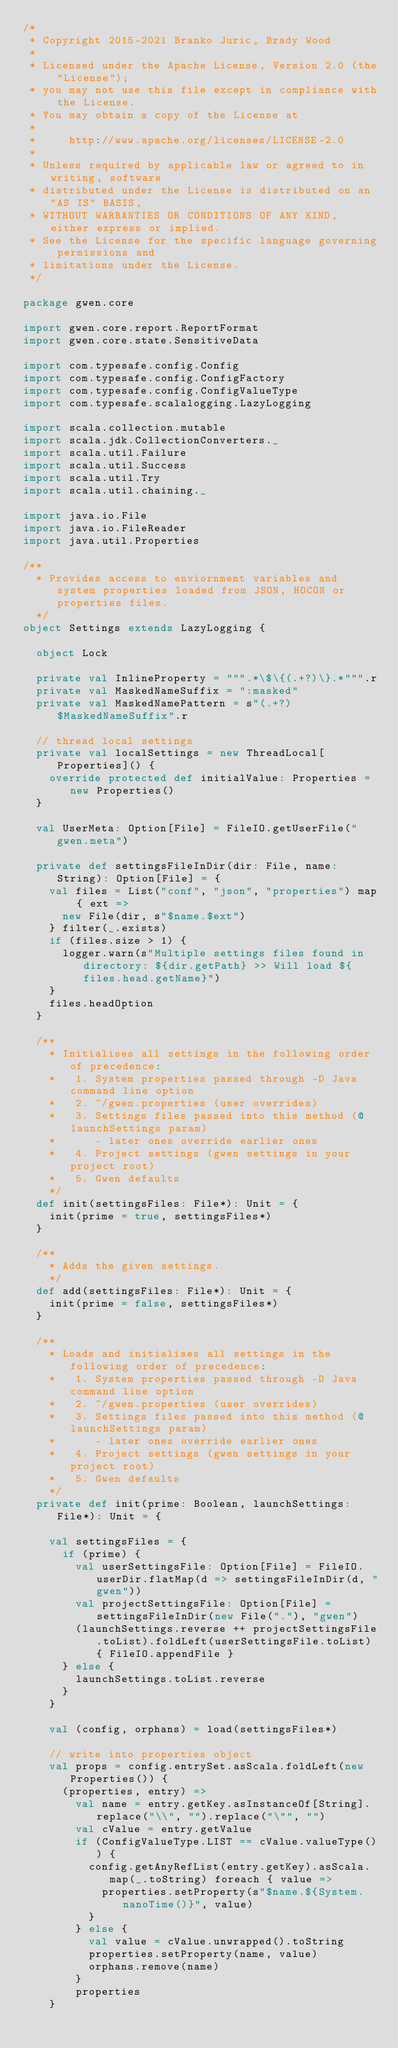Convert code to text. <code><loc_0><loc_0><loc_500><loc_500><_Scala_>/*
 * Copyright 2015-2021 Branko Juric, Brady Wood
 * 
 * Licensed under the Apache License, Version 2.0 (the "License");
 * you may not use this file except in compliance with the License.
 * You may obtain a copy of the License at
 * 
 *     http://www.apache.org/licenses/LICENSE-2.0
 * 
 * Unless required by applicable law or agreed to in writing, software
 * distributed under the License is distributed on an "AS IS" BASIS,
 * WITHOUT WARRANTIES OR CONDITIONS OF ANY KIND, either express or implied.
 * See the License for the specific language governing permissions and
 * limitations under the License.
 */

package gwen.core

import gwen.core.report.ReportFormat
import gwen.core.state.SensitiveData

import com.typesafe.config.Config
import com.typesafe.config.ConfigFactory
import com.typesafe.config.ConfigValueType
import com.typesafe.scalalogging.LazyLogging

import scala.collection.mutable
import scala.jdk.CollectionConverters._
import scala.util.Failure
import scala.util.Success
import scala.util.Try
import scala.util.chaining._

import java.io.File
import java.io.FileReader
import java.util.Properties

/**
  * Provides access to enviornment variables and system properties loaded from JSON, HOCON or properties files. 
  */
object Settings extends LazyLogging {

  object Lock

  private val InlineProperty = """.*\$\{(.+?)\}.*""".r
  private val MaskedNameSuffix = ":masked"
  private val MaskedNamePattern = s"(.+?)$MaskedNameSuffix".r

  // thread local settings
  private val localSettings = new ThreadLocal[Properties]() {
    override protected def initialValue: Properties = new Properties()
  }

  val UserMeta: Option[File] = FileIO.getUserFile("gwen.meta")

  private def settingsFileInDir(dir: File, name: String): Option[File] = {
    val files = List("conf", "json", "properties") map { ext => 
      new File(dir, s"$name.$ext")
    } filter(_.exists)
    if (files.size > 1) {
      logger.warn(s"Multiple settings files found in directory: ${dir.getPath} >> Will load ${files.head.getName}")
    }
    files.headOption
  } 

  /**
    * Initialises all settings in the following order of precedence:
    *   1. System properties passed through -D Java command line option
    *   2. ~/gwen.properties (user overrides)
    *   3. Settings files passed into this method (@launchSettings param)
    *      - later ones override earlier ones
    *   4. Project settings (gwen settings in your project root)
    *   5. Gwen defaults
    */
  def init(settingsFiles: File*): Unit = {
    init(prime = true, settingsFiles*)
  }

  /**
    * Adds the given settings.
    */
  def add(settingsFiles: File*): Unit = {
    init(prime = false, settingsFiles*)
  }

  /**
    * Loads and initialises all settings in the following order of precedence:
    *   1. System properties passed through -D Java command line option
    *   2. ~/gwen.properties (user overrides)
    *   3. Settings files passed into this method (@launchSettings param)
    *      - later ones override earlier ones
    *   4. Project settings (gwen settings in your project root)
    *   5. Gwen defaults
    */
  private def init(prime: Boolean, launchSettings: File*): Unit = {

    val settingsFiles = {
      if (prime) {
        val userSettingsFile: Option[File] = FileIO.userDir.flatMap(d => settingsFileInDir(d, "gwen"))
        val projectSettingsFile: Option[File] = settingsFileInDir(new File("."), "gwen")
        (launchSettings.reverse ++ projectSettingsFile.toList).foldLeft(userSettingsFile.toList) { FileIO.appendFile }
      } else {
        launchSettings.toList.reverse
      }
    }

    val (config, orphans) = load(settingsFiles*)
    
    // write into properties object
    val props = config.entrySet.asScala.foldLeft(new Properties()) {
      (properties, entry) =>
        val name = entry.getKey.asInstanceOf[String].replace("\\", "").replace("\"", "")
        val cValue = entry.getValue
        if (ConfigValueType.LIST == cValue.valueType()) {
          config.getAnyRefList(entry.getKey).asScala.map(_.toString) foreach { value => 
            properties.setProperty(s"$name.${System.nanoTime()}", value)
          }
        } else {
          val value = cValue.unwrapped().toString
          properties.setProperty(name, value)
          orphans.remove(name)
        }
        properties
    }</code> 